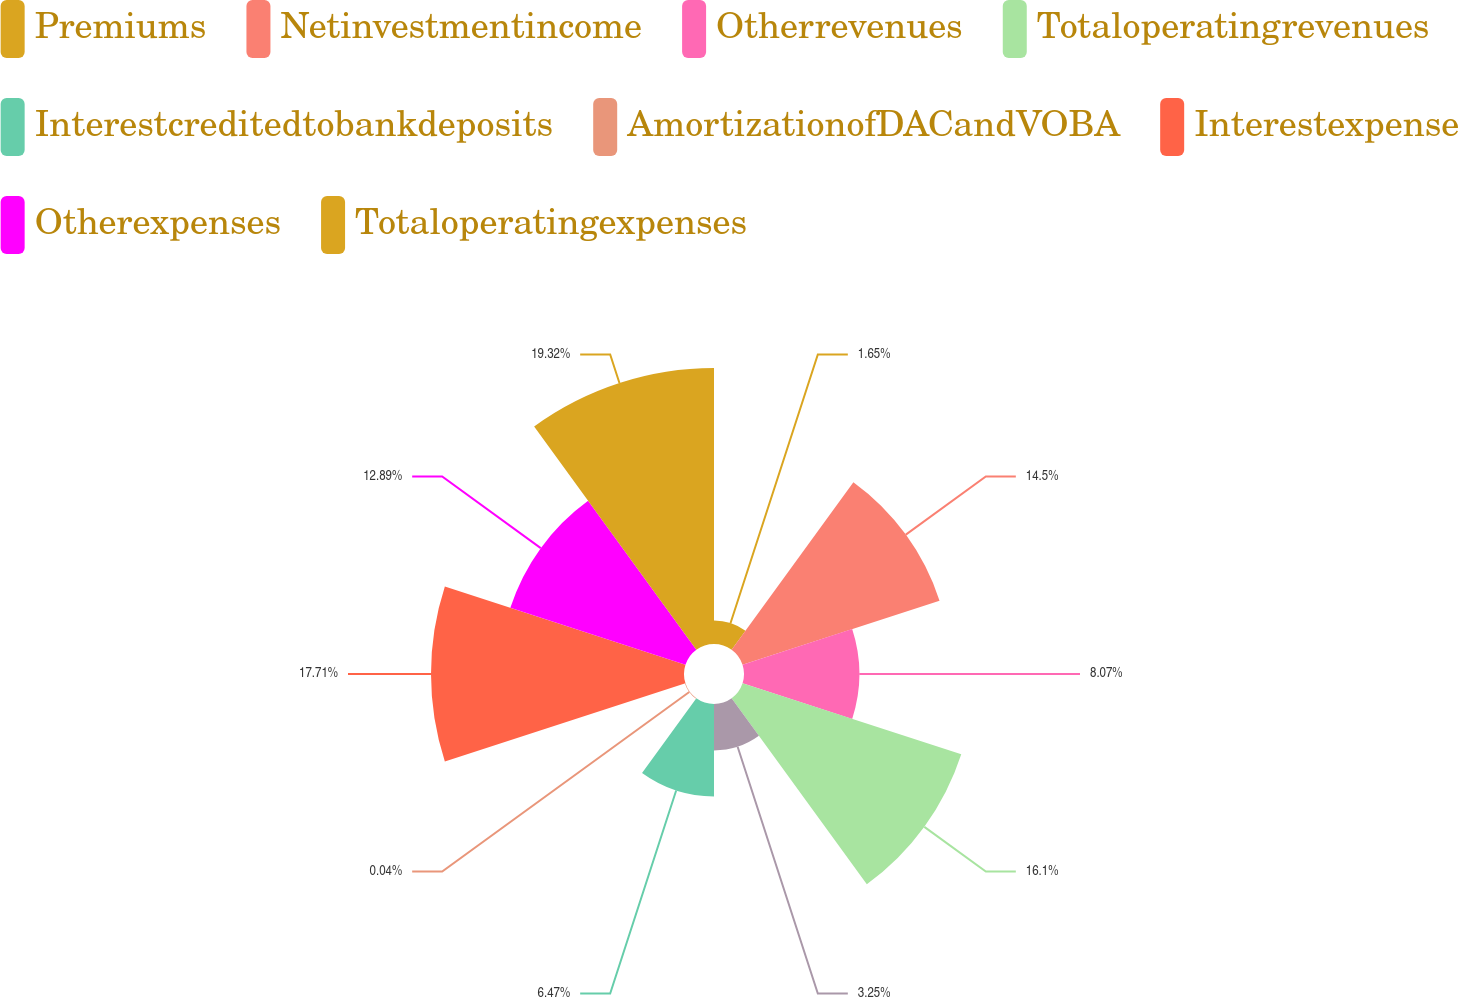<chart> <loc_0><loc_0><loc_500><loc_500><pie_chart><fcel>Premiums<fcel>Netinvestmentincome<fcel>Otherrevenues<fcel>Totaloperatingrevenues<fcel>Unnamed: 4<fcel>Interestcreditedtobankdeposits<fcel>AmortizationofDACandVOBA<fcel>Interestexpense<fcel>Otherexpenses<fcel>Totaloperatingexpenses<nl><fcel>1.65%<fcel>14.5%<fcel>8.07%<fcel>16.1%<fcel>3.25%<fcel>6.47%<fcel>0.04%<fcel>17.71%<fcel>12.89%<fcel>19.32%<nl></chart> 